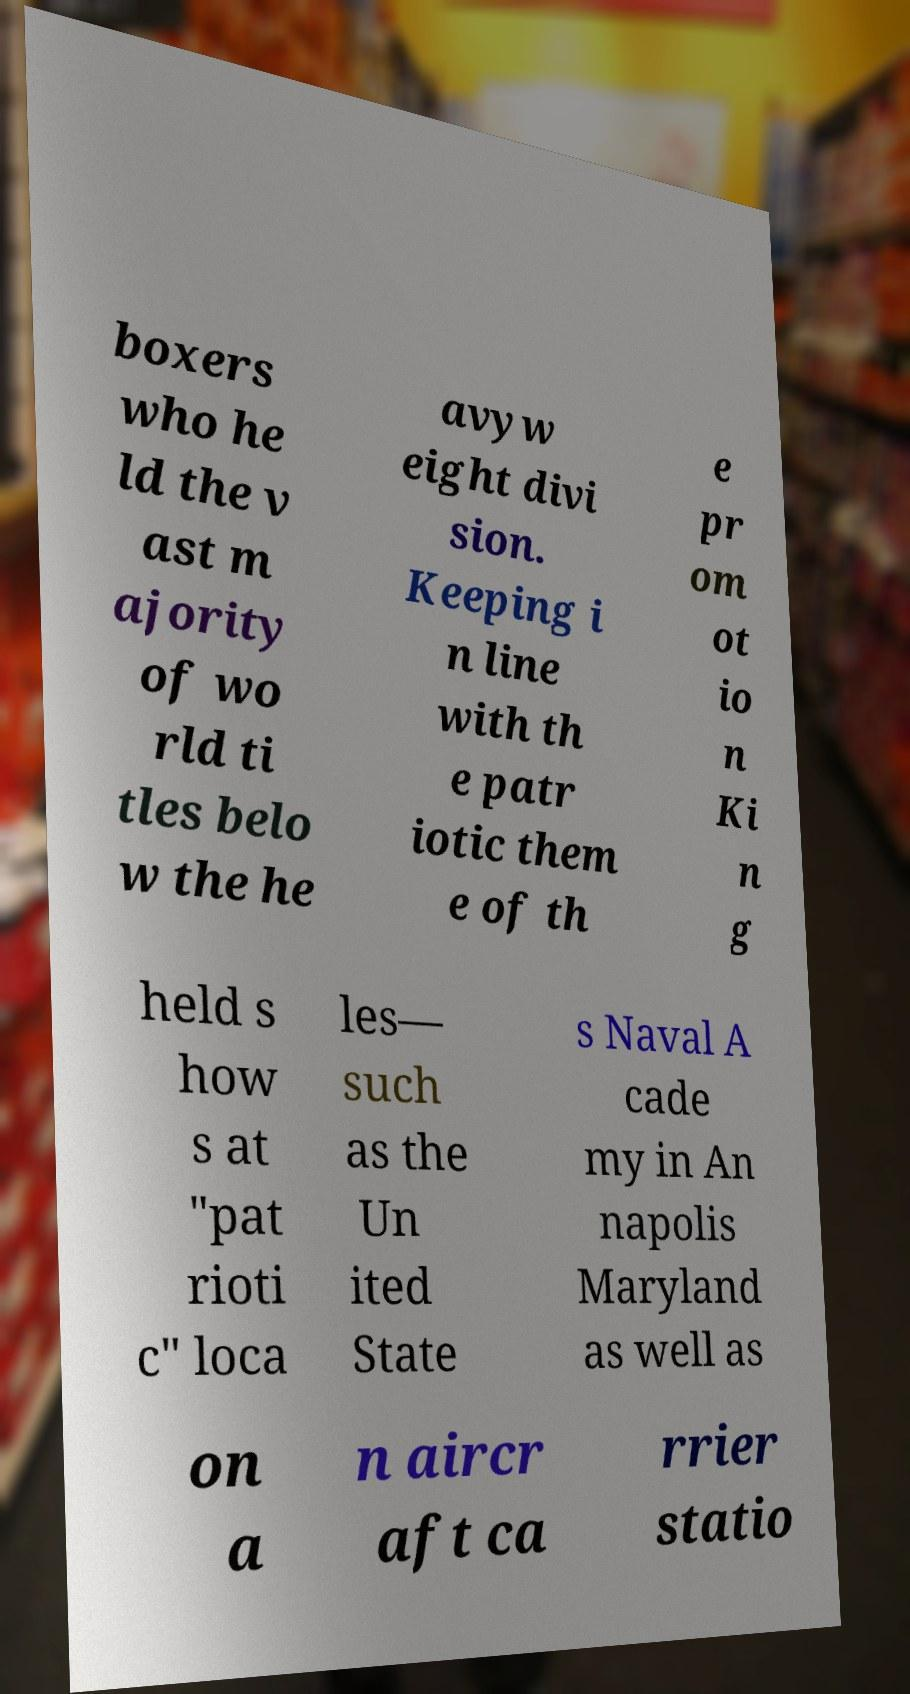Can you accurately transcribe the text from the provided image for me? boxers who he ld the v ast m ajority of wo rld ti tles belo w the he avyw eight divi sion. Keeping i n line with th e patr iotic them e of th e pr om ot io n Ki n g held s how s at "pat rioti c" loca les— such as the Un ited State s Naval A cade my in An napolis Maryland as well as on a n aircr aft ca rrier statio 